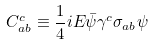<formula> <loc_0><loc_0><loc_500><loc_500>C ^ { c } _ { a b } \equiv \frac { 1 } { 4 } i E \bar { \psi } \gamma ^ { c } \sigma _ { a b } \psi</formula> 